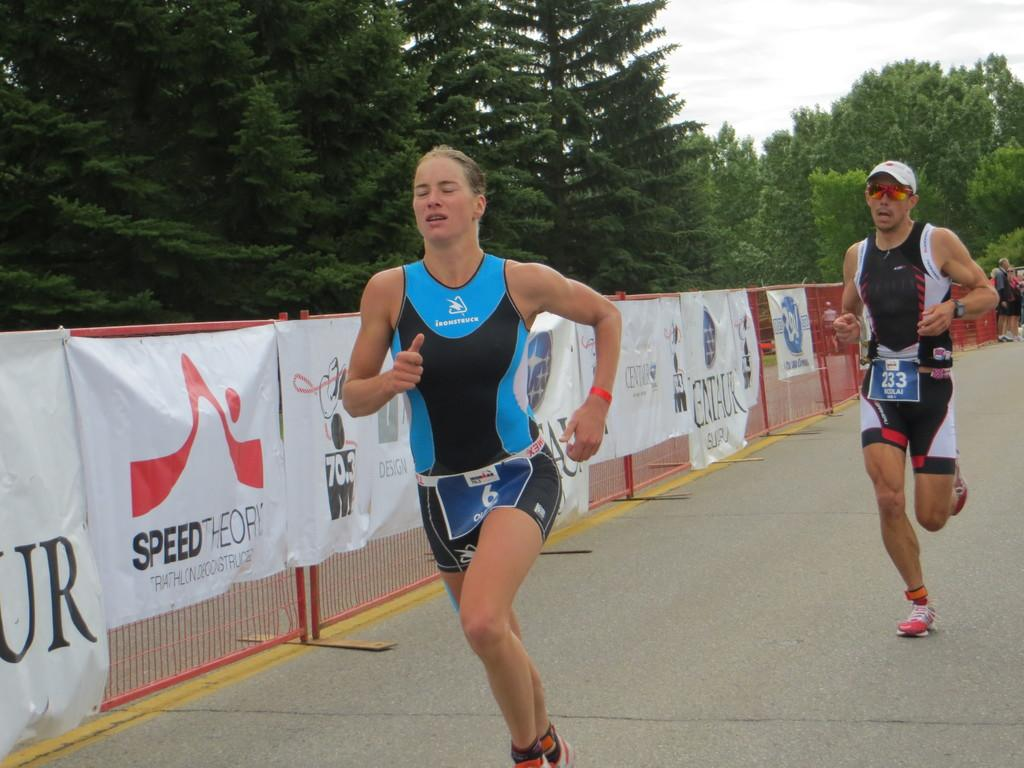<image>
Provide a brief description of the given image. Runner #6 and runner #233 compete in a race on a road lined with advertisments by Speed Theory and many more. 